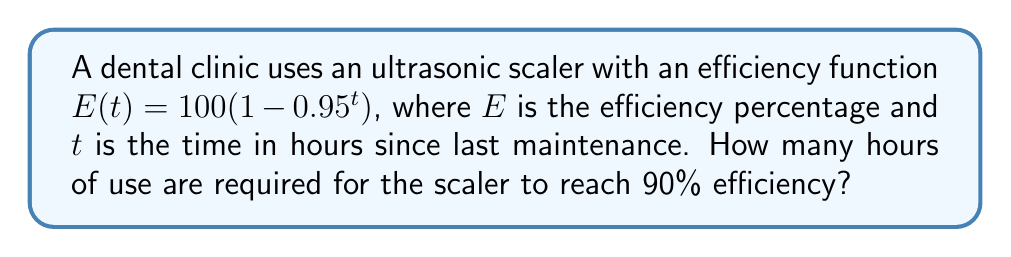What is the answer to this math problem? Let's approach this step-by-step:

1) We want to find $t$ when $E(t) = 90$. So, we set up the equation:

   $90 = 100(1 - 0.95^t)$

2) Divide both sides by 100:

   $0.9 = 1 - 0.95^t$

3) Subtract both sides from 1:

   $0.1 = 0.95^t$

4) Take the natural logarithm of both sides:

   $\ln(0.1) = \ln(0.95^t)$

5) Use the logarithm property $\ln(a^b) = b\ln(a)$:

   $\ln(0.1) = t\ln(0.95)$

6) Solve for $t$:

   $t = \frac{\ln(0.1)}{\ln(0.95)}$

7) Calculate this value:

   $t \approx 44.3561$ hours

8) Since we're dealing with hours of use, we round up to the nearest hour.
Answer: 45 hours 